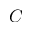<formula> <loc_0><loc_0><loc_500><loc_500>C</formula> 